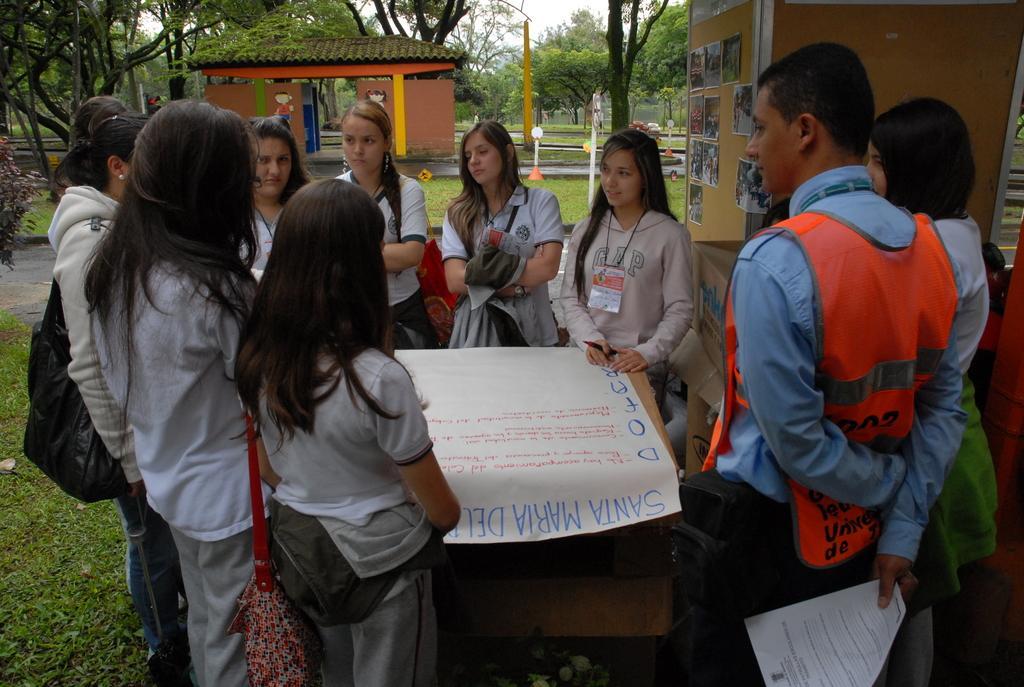In one or two sentences, can you explain what this image depicts? In this image we can see many people. Some are wearing bags. And there is a box. On that there is a paper with something written on that. On the ground there is grass. In the background there are trees. Also there is a shed. And there is a pillar. And there are papers pasted on the pillar. 